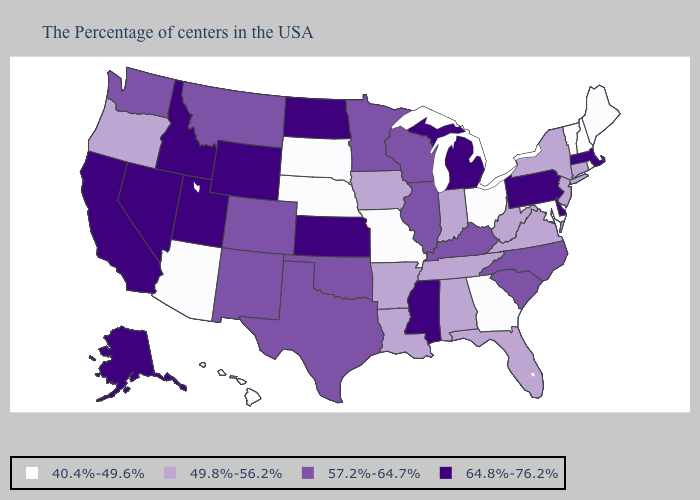What is the highest value in the USA?
Concise answer only. 64.8%-76.2%. Name the states that have a value in the range 64.8%-76.2%?
Answer briefly. Massachusetts, Delaware, Pennsylvania, Michigan, Mississippi, Kansas, North Dakota, Wyoming, Utah, Idaho, Nevada, California, Alaska. What is the value of Arkansas?
Concise answer only. 49.8%-56.2%. Does New Hampshire have the lowest value in the USA?
Write a very short answer. Yes. Name the states that have a value in the range 64.8%-76.2%?
Write a very short answer. Massachusetts, Delaware, Pennsylvania, Michigan, Mississippi, Kansas, North Dakota, Wyoming, Utah, Idaho, Nevada, California, Alaska. What is the highest value in the West ?
Be succinct. 64.8%-76.2%. Name the states that have a value in the range 57.2%-64.7%?
Write a very short answer. North Carolina, South Carolina, Kentucky, Wisconsin, Illinois, Minnesota, Oklahoma, Texas, Colorado, New Mexico, Montana, Washington. What is the value of New Hampshire?
Short answer required. 40.4%-49.6%. Is the legend a continuous bar?
Concise answer only. No. Name the states that have a value in the range 64.8%-76.2%?
Keep it brief. Massachusetts, Delaware, Pennsylvania, Michigan, Mississippi, Kansas, North Dakota, Wyoming, Utah, Idaho, Nevada, California, Alaska. Does the first symbol in the legend represent the smallest category?
Write a very short answer. Yes. Which states hav the highest value in the South?
Quick response, please. Delaware, Mississippi. Name the states that have a value in the range 40.4%-49.6%?
Be succinct. Maine, Rhode Island, New Hampshire, Vermont, Maryland, Ohio, Georgia, Missouri, Nebraska, South Dakota, Arizona, Hawaii. What is the value of Montana?
Quick response, please. 57.2%-64.7%. Name the states that have a value in the range 40.4%-49.6%?
Answer briefly. Maine, Rhode Island, New Hampshire, Vermont, Maryland, Ohio, Georgia, Missouri, Nebraska, South Dakota, Arizona, Hawaii. 